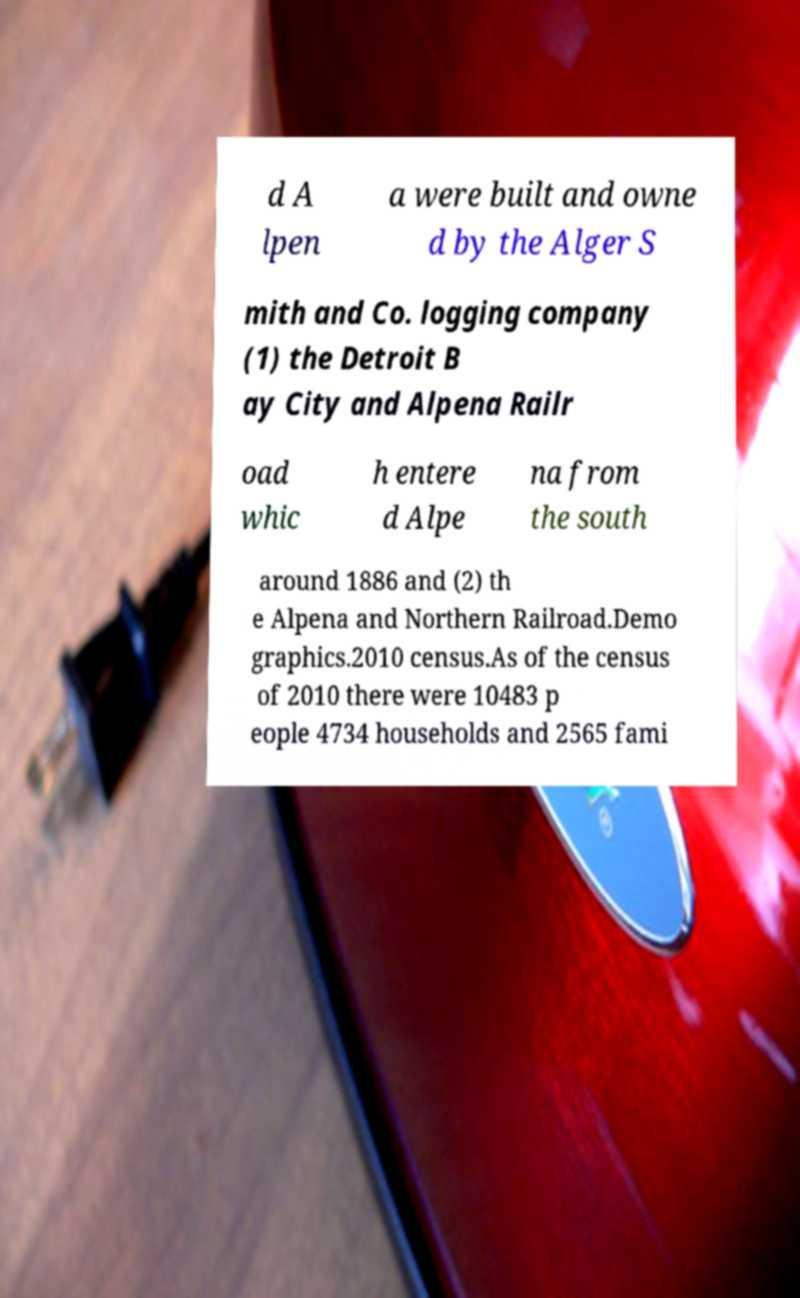I need the written content from this picture converted into text. Can you do that? d A lpen a were built and owne d by the Alger S mith and Co. logging company (1) the Detroit B ay City and Alpena Railr oad whic h entere d Alpe na from the south around 1886 and (2) th e Alpena and Northern Railroad.Demo graphics.2010 census.As of the census of 2010 there were 10483 p eople 4734 households and 2565 fami 